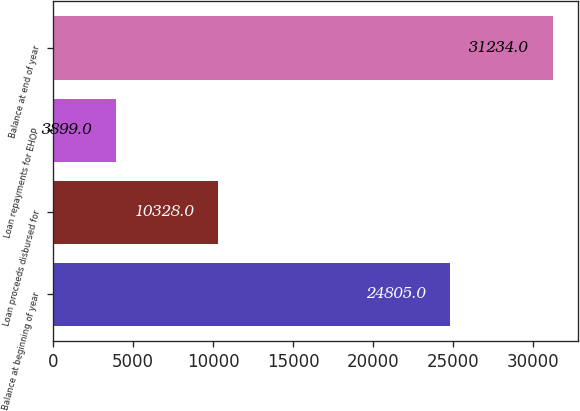<chart> <loc_0><loc_0><loc_500><loc_500><bar_chart><fcel>Balance at beginning of year<fcel>Loan proceeds disbursed for<fcel>Loan repayments for EHOP<fcel>Balance at end of year<nl><fcel>24805<fcel>10328<fcel>3899<fcel>31234<nl></chart> 